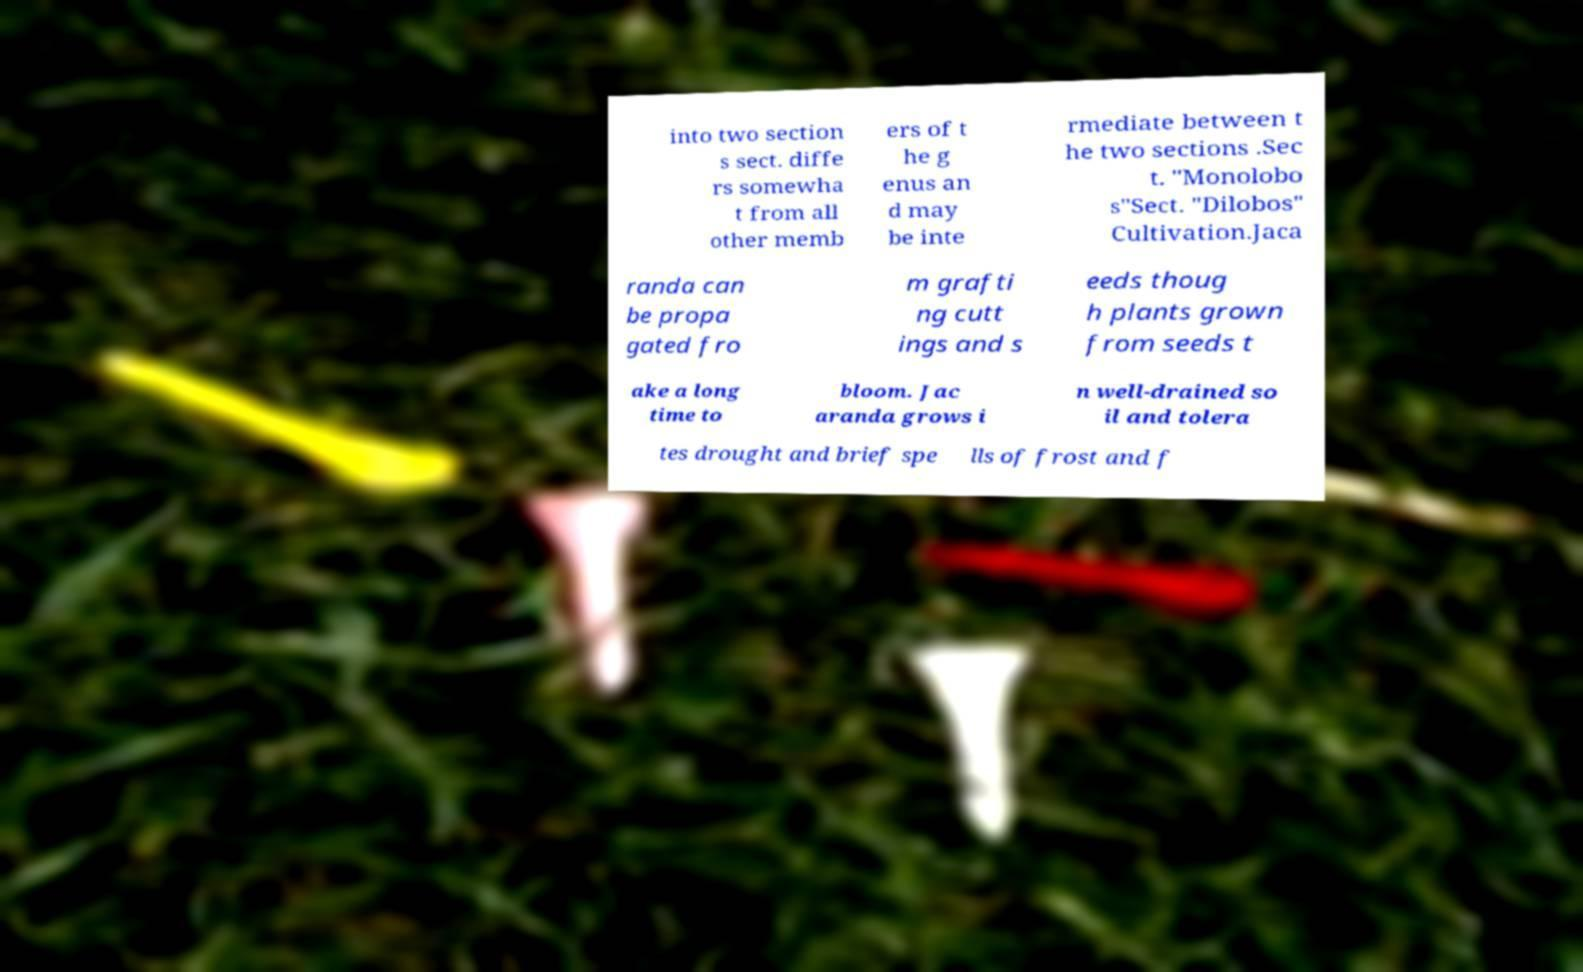There's text embedded in this image that I need extracted. Can you transcribe it verbatim? into two section s sect. diffe rs somewha t from all other memb ers of t he g enus an d may be inte rmediate between t he two sections .Sec t. "Monolobo s"Sect. "Dilobos" Cultivation.Jaca randa can be propa gated fro m grafti ng cutt ings and s eeds thoug h plants grown from seeds t ake a long time to bloom. Jac aranda grows i n well-drained so il and tolera tes drought and brief spe lls of frost and f 